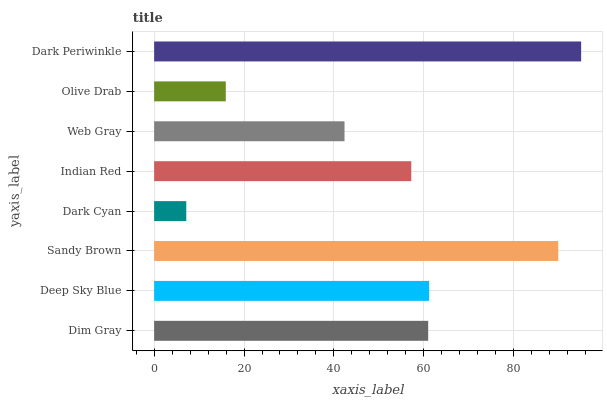Is Dark Cyan the minimum?
Answer yes or no. Yes. Is Dark Periwinkle the maximum?
Answer yes or no. Yes. Is Deep Sky Blue the minimum?
Answer yes or no. No. Is Deep Sky Blue the maximum?
Answer yes or no. No. Is Deep Sky Blue greater than Dim Gray?
Answer yes or no. Yes. Is Dim Gray less than Deep Sky Blue?
Answer yes or no. Yes. Is Dim Gray greater than Deep Sky Blue?
Answer yes or no. No. Is Deep Sky Blue less than Dim Gray?
Answer yes or no. No. Is Dim Gray the high median?
Answer yes or no. Yes. Is Indian Red the low median?
Answer yes or no. Yes. Is Deep Sky Blue the high median?
Answer yes or no. No. Is Dark Periwinkle the low median?
Answer yes or no. No. 